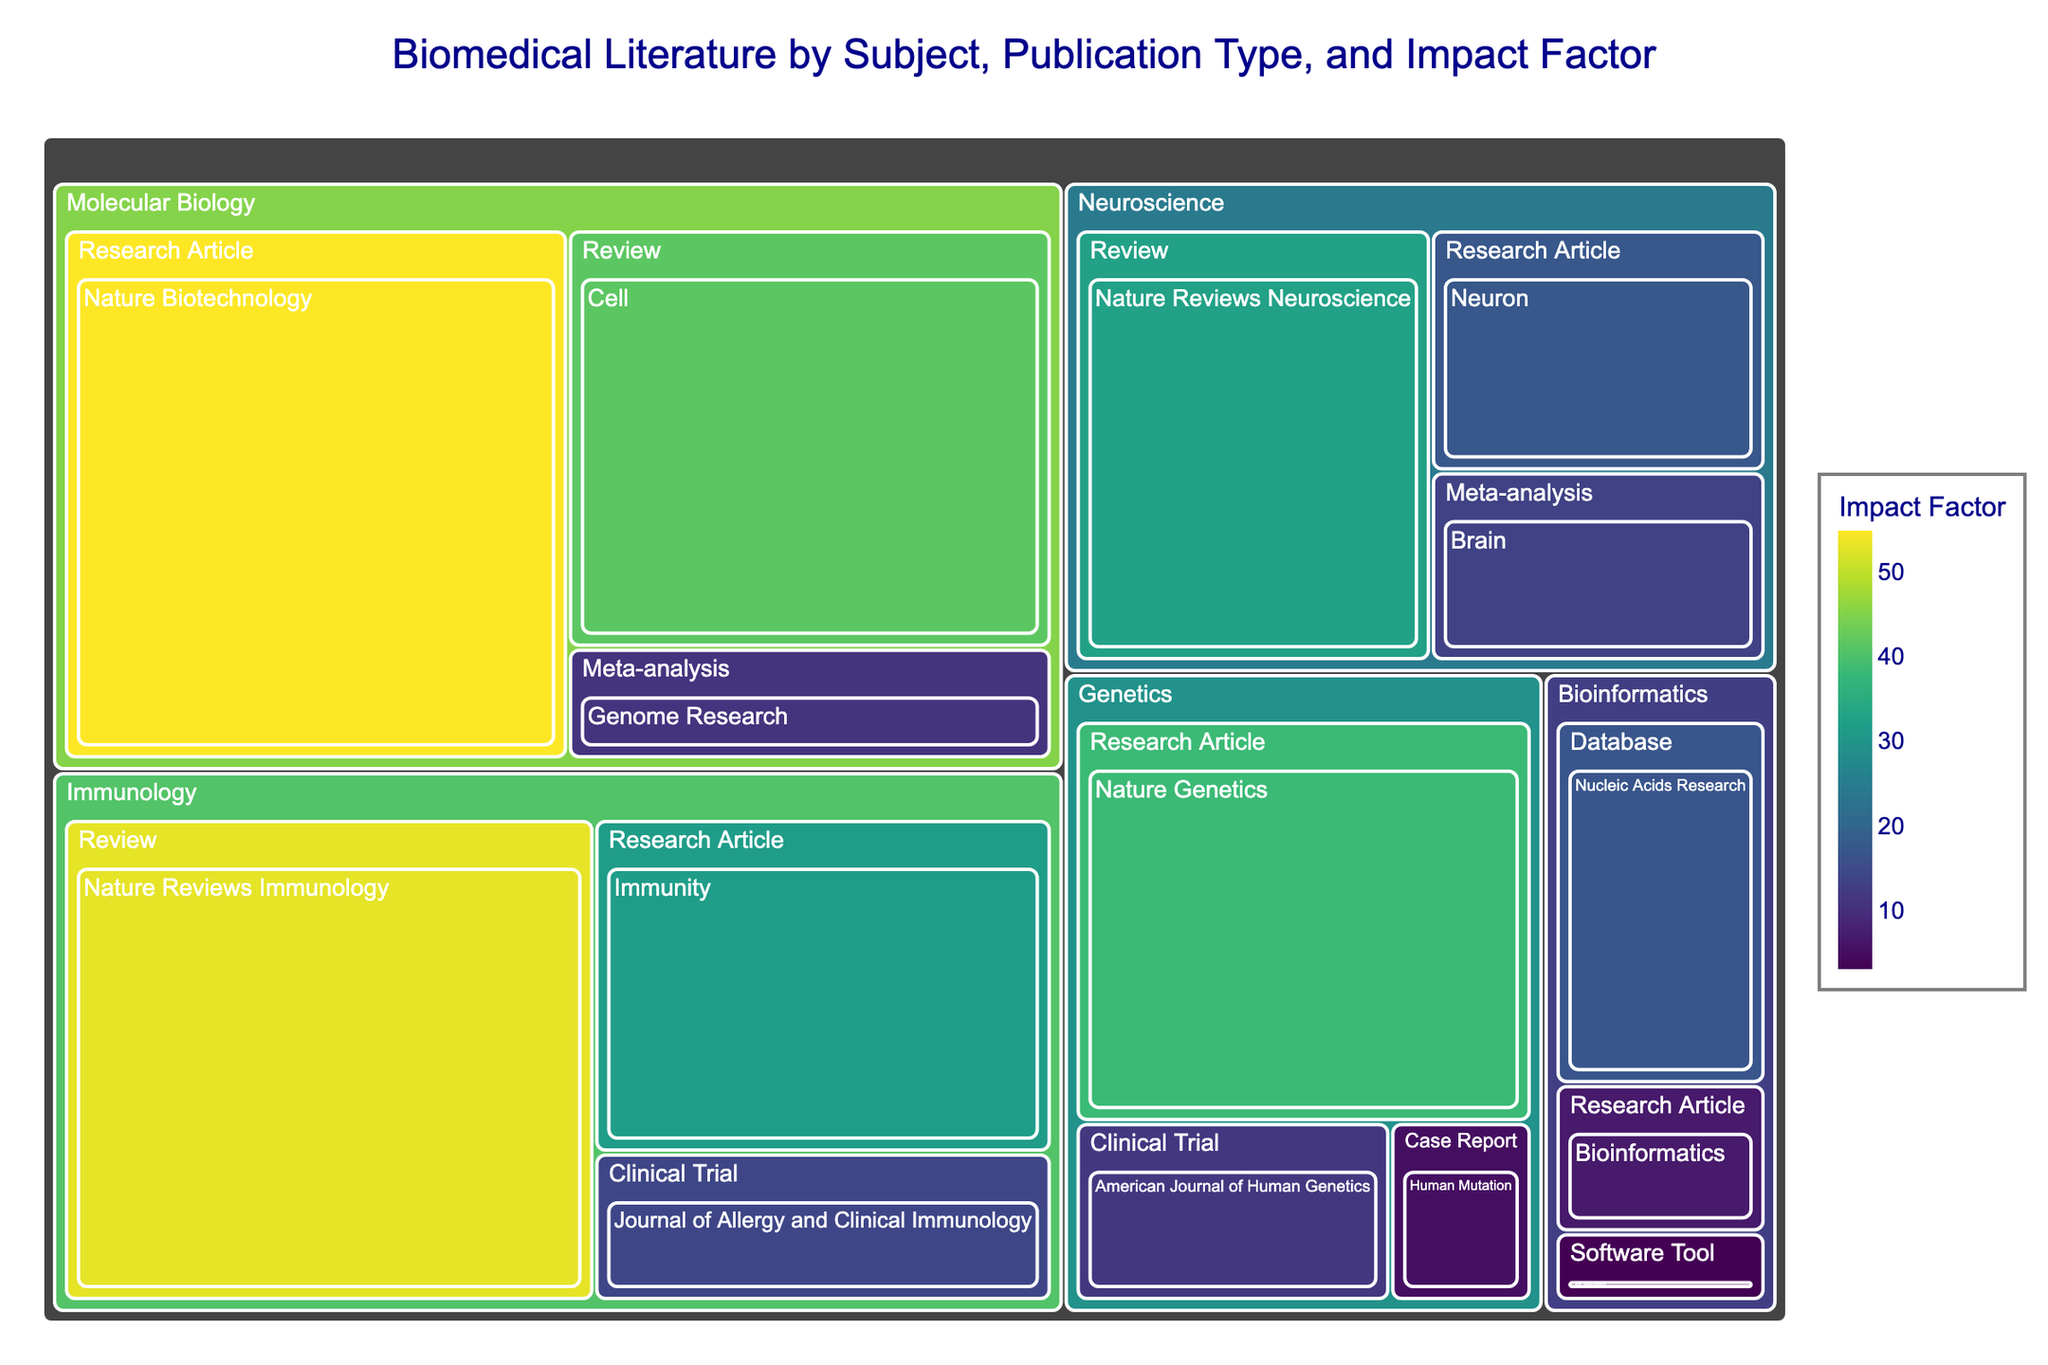Which subject area has the highest impact factor? By visually scanning the treemap, we can identify the subject area with the largest tile colored by the highest intensity shade of the color chosen for the impact factor, which is likely to indicate a higher value.
Answer: Molecular Biology What is the impact factor of the journal "Nature Reviews Immunology"? Locate the tile for the journal "Nature Reviews Immunology" and read the associated impact factor value from the figure's labels or hover information.
Answer: 53.1 Which publication type within Immunology has the highest impact factor? In the Immunology section of the treemap, compare the impact factors of all publication types (Research Article, Review, Clinical Trial) and identify the highest value.
Answer: Review Compare the impact factors of "Neuron" and "Brain" in the Neuroscience subject area. Which one is higher? Find the tiles for "Neuron" and "Brain" within the Neuroscience section and compare their listed impact factors.
Answer: Neuron What is the difference in impact factor between "Nature Biotechnology" and "Cell" within Molecular Biology? Identify the impact factors for "Nature Biotechnology" and "Cell" and subtract the lower value from the higher value to find the difference.
Answer: 13.3 How many journals in the dataset have an impact factor higher than 20? Count the number of tiles in the treemap that have an impact factor value greater than 20.
Answer: 5 What is the total impact factor for all journals under the Genetics subject area? Sum the impact factors for all journals within the Genetics section of the treemap.
Answer: 55.4 Which subject area has the smallest representation in terms of the number of publication types? Count the number of distinct publication types for each subject area and identify the area with the fewest types.
Answer: Bioinformatics In the Genomics subject area, what is the impact factor of the "Meta-analysis" publication type? Find the "Meta-analysis" tile within the Genomics section and read the impact factor from the figure.
Answer: 11.1 What is the average impact factor of journals in the Bioinformatics subject area? Identify all impact factors in the Bioinformatics section and compute the arithmetic mean by summing the values and dividing by the number of journals.
Answer: 9.0 